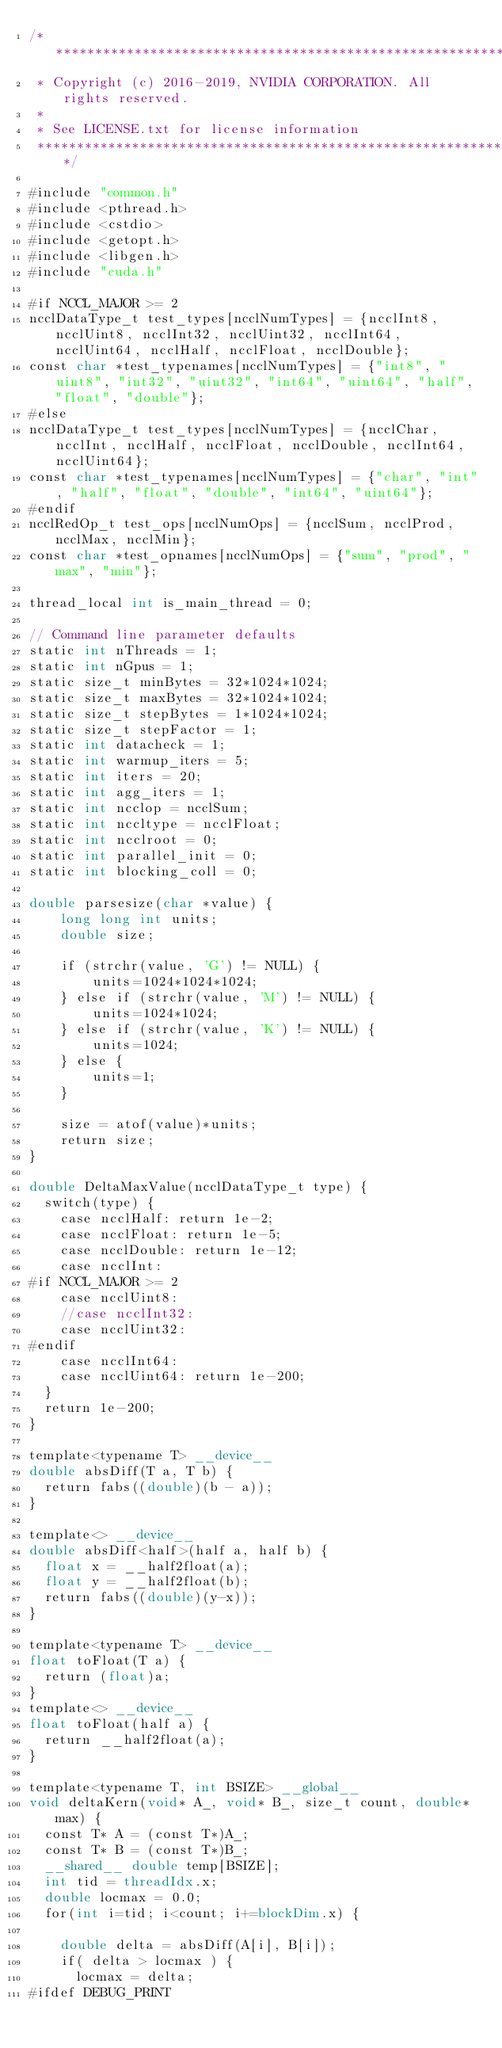<code> <loc_0><loc_0><loc_500><loc_500><_Cuda_>/*************************************************************************
 * Copyright (c) 2016-2019, NVIDIA CORPORATION. All rights reserved.
 *
 * See LICENSE.txt for license information
 ************************************************************************/

#include "common.h"
#include <pthread.h>
#include <cstdio>
#include <getopt.h>
#include <libgen.h>
#include "cuda.h"

#if NCCL_MAJOR >= 2
ncclDataType_t test_types[ncclNumTypes] = {ncclInt8, ncclUint8, ncclInt32, ncclUint32, ncclInt64, ncclUint64, ncclHalf, ncclFloat, ncclDouble};
const char *test_typenames[ncclNumTypes] = {"int8", "uint8", "int32", "uint32", "int64", "uint64", "half", "float", "double"};
#else
ncclDataType_t test_types[ncclNumTypes] = {ncclChar, ncclInt, ncclHalf, ncclFloat, ncclDouble, ncclInt64, ncclUint64};
const char *test_typenames[ncclNumTypes] = {"char", "int", "half", "float", "double", "int64", "uint64"};
#endif
ncclRedOp_t test_ops[ncclNumOps] = {ncclSum, ncclProd, ncclMax, ncclMin};
const char *test_opnames[ncclNumOps] = {"sum", "prod", "max", "min"};

thread_local int is_main_thread = 0;

// Command line parameter defaults
static int nThreads = 1;
static int nGpus = 1;
static size_t minBytes = 32*1024*1024;
static size_t maxBytes = 32*1024*1024;
static size_t stepBytes = 1*1024*1024;
static size_t stepFactor = 1;
static int datacheck = 1;
static int warmup_iters = 5;
static int iters = 20;
static int agg_iters = 1;
static int ncclop = ncclSum;
static int nccltype = ncclFloat;
static int ncclroot = 0;
static int parallel_init = 0;
static int blocking_coll = 0;

double parsesize(char *value) {
    long long int units;
    double size;

    if (strchr(value, 'G') != NULL) {
        units=1024*1024*1024;
    } else if (strchr(value, 'M') != NULL) {
        units=1024*1024;
    } else if (strchr(value, 'K') != NULL) {
        units=1024;
    } else {
        units=1;
    }

    size = atof(value)*units;
    return size;
}

double DeltaMaxValue(ncclDataType_t type) {
  switch(type) {
    case ncclHalf: return 1e-2;
    case ncclFloat: return 1e-5;
    case ncclDouble: return 1e-12;
    case ncclInt:
#if NCCL_MAJOR >= 2
    case ncclUint8:
    //case ncclInt32:
    case ncclUint32:
#endif
    case ncclInt64:
    case ncclUint64: return 1e-200;
  }
  return 1e-200;
}

template<typename T> __device__
double absDiff(T a, T b) {
  return fabs((double)(b - a));
}

template<> __device__
double absDiff<half>(half a, half b) {
  float x = __half2float(a);
  float y = __half2float(b);
  return fabs((double)(y-x));
}

template<typename T> __device__
float toFloat(T a) {
  return (float)a;
}
template<> __device__
float toFloat(half a) {
  return __half2float(a);
}

template<typename T, int BSIZE> __global__
void deltaKern(void* A_, void* B_, size_t count, double* max) {
  const T* A = (const T*)A_;
  const T* B = (const T*)B_;
  __shared__ double temp[BSIZE];
  int tid = threadIdx.x;
  double locmax = 0.0;
  for(int i=tid; i<count; i+=blockDim.x) {

    double delta = absDiff(A[i], B[i]);
    if( delta > locmax ) {
      locmax = delta;
#ifdef DEBUG_PRINT</code> 